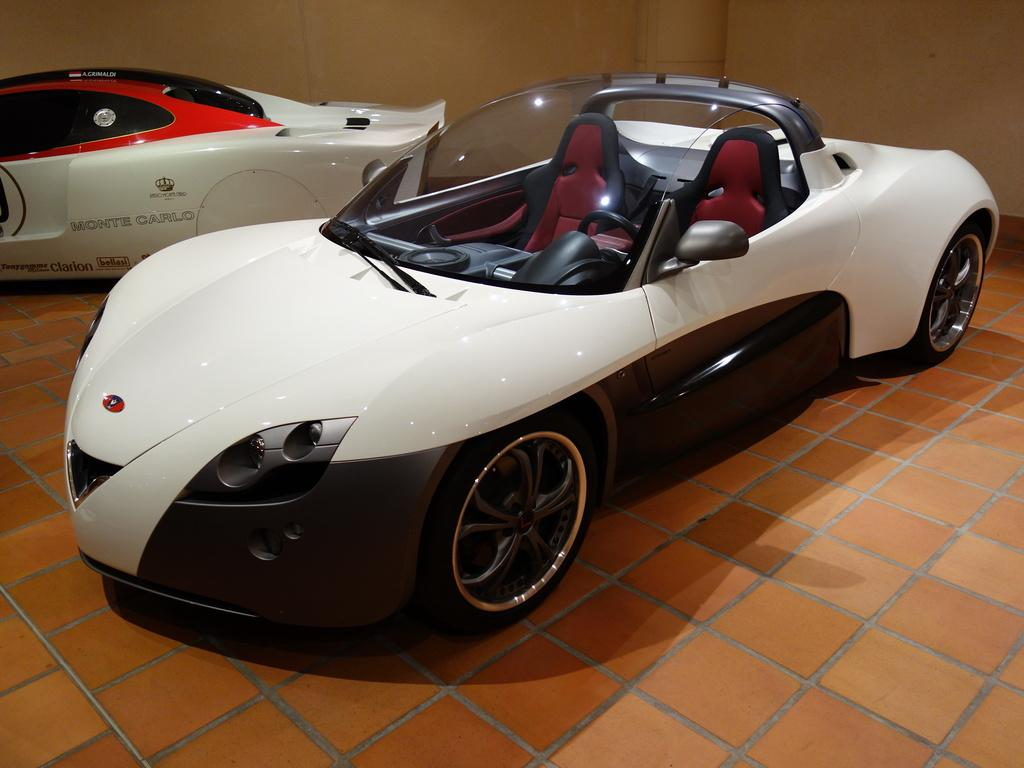What can be seen in the image that is used for transportation? There are vehicles in the image that are used for transportation. What type of flooring is visible in the image? The floor in the image is tiled. What is present in the background of the image? There is a wall in the image. Can you describe any additional details about the vehicles in the image? Something is written on at least one of the vehicles. Can you tell me how many pairs of shoes are visible in the image? There are no shoes present in the image. What type of book can be seen on the wall in the image? There is no book present in the image; it only features vehicles, a tiled floor, and a wall. 